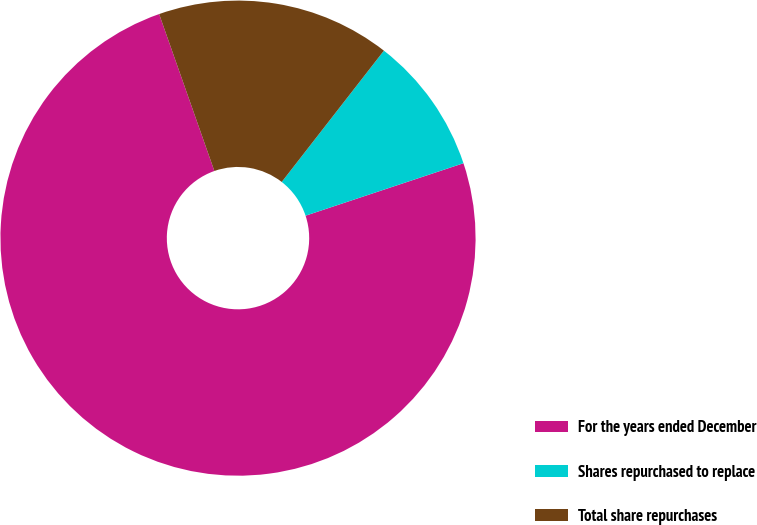Convert chart to OTSL. <chart><loc_0><loc_0><loc_500><loc_500><pie_chart><fcel>For the years ended December<fcel>Shares repurchased to replace<fcel>Total share repurchases<nl><fcel>74.72%<fcel>9.37%<fcel>15.91%<nl></chart> 